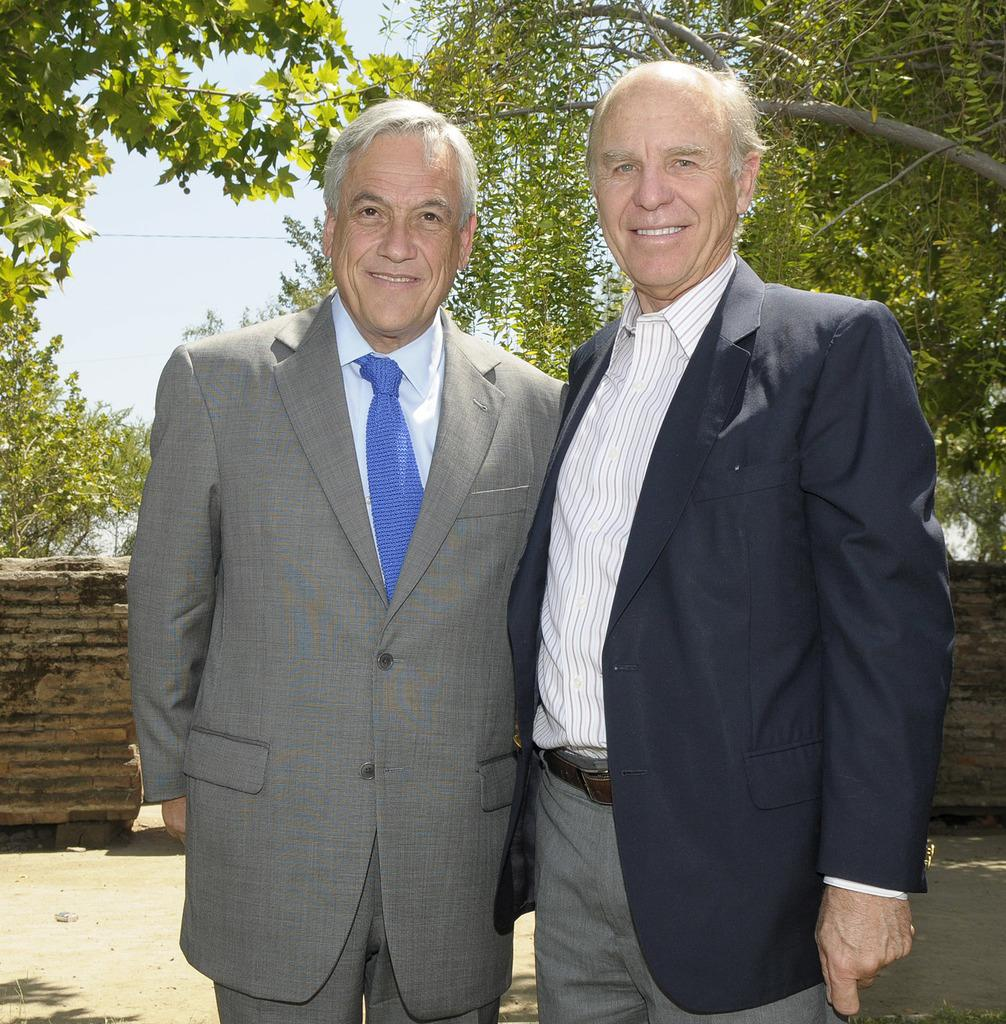How many people are in the image? There are two men in the image. What are the men doing in the image? The men are standing and smiling. What are the men wearing in the image? The men are wearing suits. What can be seen in the background of the image? There are trees, a wall, and the sky visible in the background of the image. How many baby cows are visible in the image? There are no baby cows present in the image. What type of paper is the man holding in the image? There is no paper visible in the image; the men are wearing suits and standing with no visible objects in their hands. 